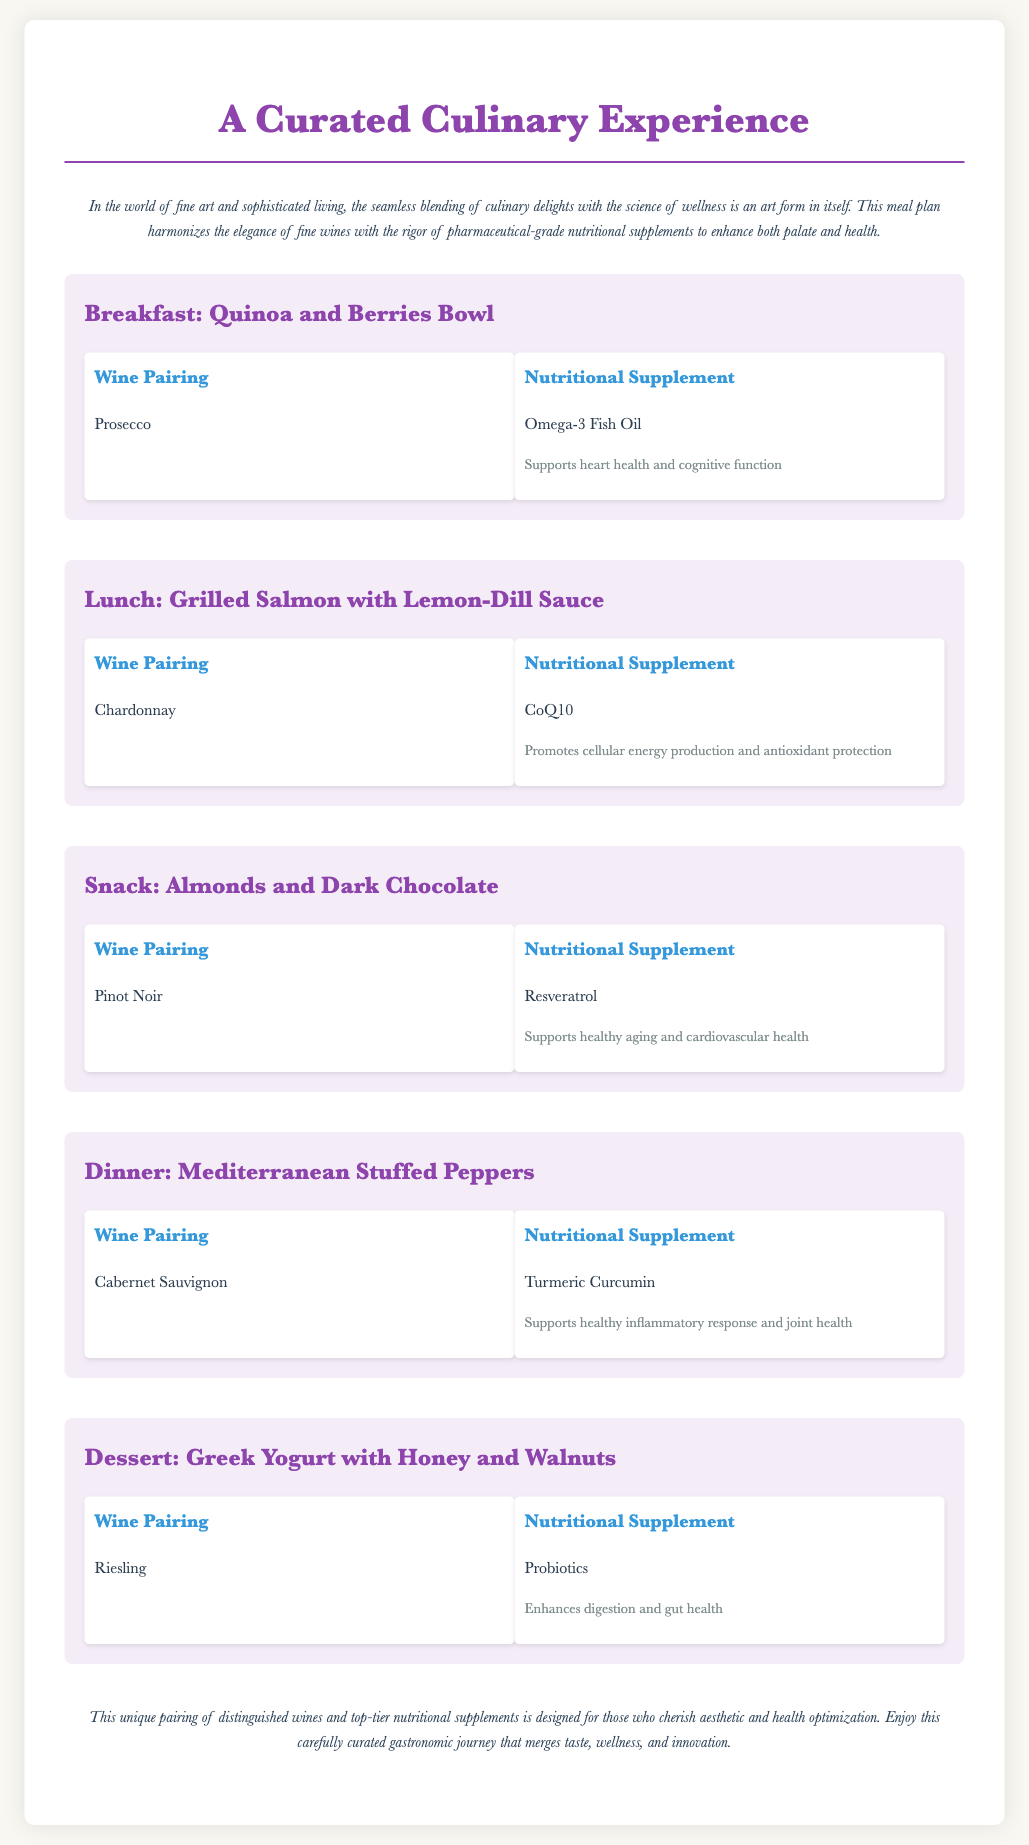What is the breakfast meal? The breakfast meal is explicitly stated in the meal plan and is titled "Breakfast: Quinoa and Berries Bowl."
Answer: Quinoa and Berries Bowl What wine pairs with lunch? The wine pairing for lunch, "Grilled Salmon with Lemon-Dill Sauce," is mentioned as "Chardonnay."
Answer: Chardonnay What is the benefit of Omega-3 Fish Oil? The document specifies that Omega-3 Fish Oil "Supports heart health and cognitive function."
Answer: Supports heart health and cognitive function Which supplement is paired with dinner? The dinner meal features "Mediterranean Stuffed Peppers," which is paired with "Turmeric Curcumin."
Answer: Turmeric Curcumin How many meals are included in the plan? The document lists five distinct meals that are part of the curated culinary experience.
Answer: Five What type of wine is suggested for dessert? The dessert meal, "Greek Yogurt with Honey and Walnuts," recommends pairing with "Riesling."
Answer: Riesling What is the purpose of the meal plan? The introduction describes the purpose as enhancing "both palate and health."
Answer: Enhancing both palate and health What supplement supports healthy aging? The document notes that "Resveratrol" supports healthy aging and cardiovascular health.
Answer: Resveratrol 